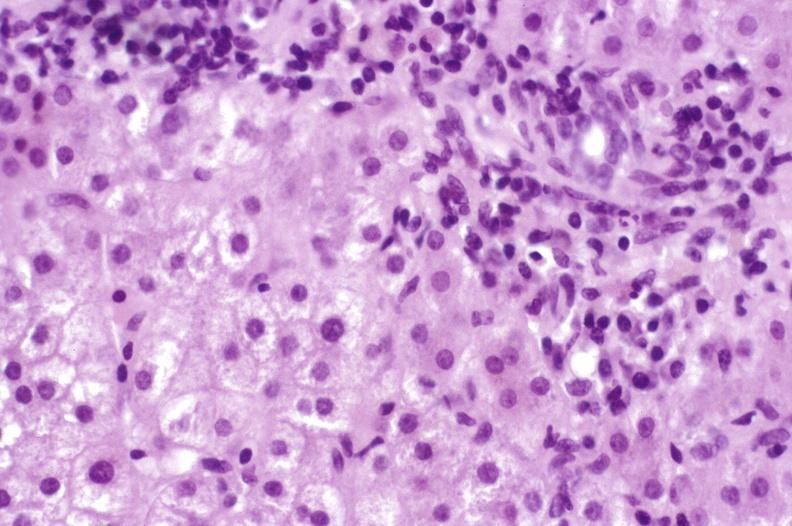s hepatobiliary present?
Answer the question using a single word or phrase. Yes 